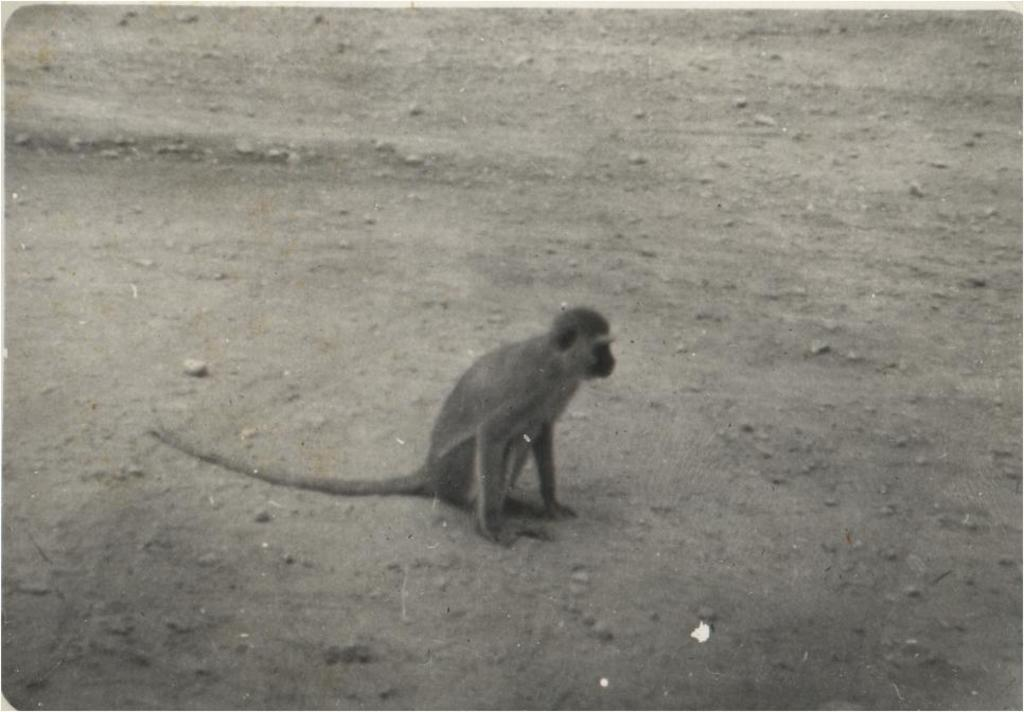What type of animal is in the image? There is a monkey in the image. Where is the monkey located in the image? The monkey is on the ground. How many pizzas are being held by the monkey in the image? There are no pizzas present in the image; it features a monkey on the ground. What type of animal is grazing in the background of the image? There is no background or other animals mentioned in the provided facts, so it cannot be determined if any other animals are present. 